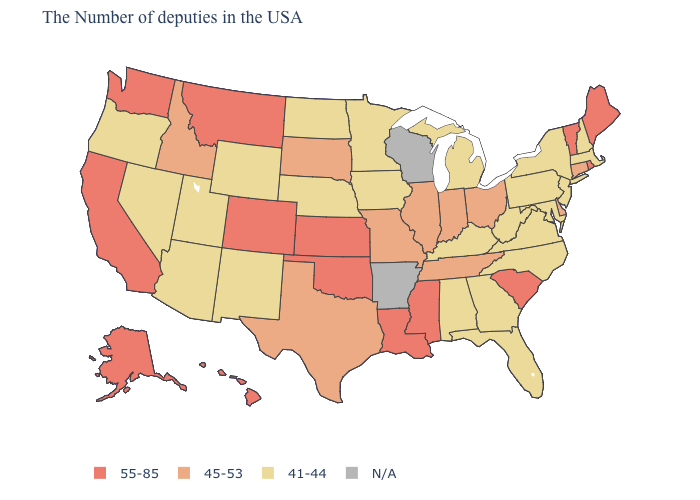What is the highest value in states that border Maryland?
Give a very brief answer. 45-53. What is the lowest value in the MidWest?
Give a very brief answer. 41-44. What is the value of Georgia?
Write a very short answer. 41-44. What is the value of North Dakota?
Be succinct. 41-44. What is the highest value in the USA?
Give a very brief answer. 55-85. Among the states that border Nevada , which have the lowest value?
Give a very brief answer. Utah, Arizona, Oregon. Among the states that border Wyoming , does Montana have the highest value?
Short answer required. Yes. What is the value of Utah?
Answer briefly. 41-44. What is the value of New Jersey?
Answer briefly. 41-44. Name the states that have a value in the range 45-53?
Keep it brief. Connecticut, Delaware, Ohio, Indiana, Tennessee, Illinois, Missouri, Texas, South Dakota, Idaho. Which states have the lowest value in the Northeast?
Quick response, please. Massachusetts, New Hampshire, New York, New Jersey, Pennsylvania. How many symbols are there in the legend?
Be succinct. 4. What is the value of Ohio?
Short answer required. 45-53. Does Alabama have the lowest value in the USA?
Give a very brief answer. Yes. 